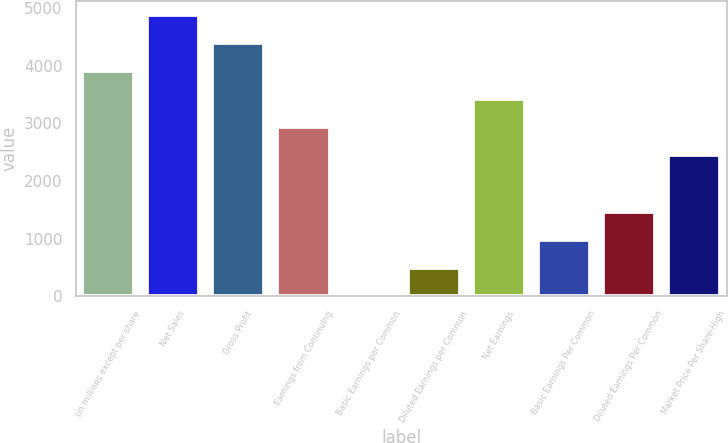Convert chart. <chart><loc_0><loc_0><loc_500><loc_500><bar_chart><fcel>(in millions except per share<fcel>Net Sales<fcel>Gross Profit<fcel>Earnings from Continuing<fcel>Basic Earnings per Common<fcel>Diluted Earnings per Common<fcel>Net Earnings<fcel>Basic Earnings Per Common<fcel>Diluted Earnings Per Common<fcel>Market Price Per Share-High<nl><fcel>3908.04<fcel>4885.04<fcel>4396.54<fcel>2931.04<fcel>0.04<fcel>488.54<fcel>3419.54<fcel>977.04<fcel>1465.54<fcel>2442.54<nl></chart> 